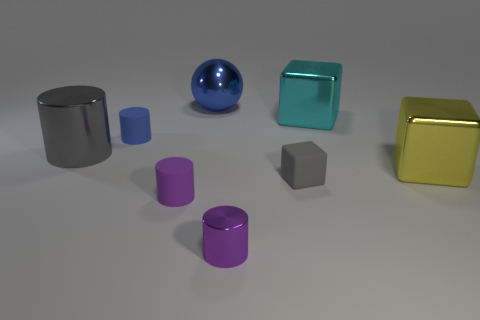Is the shape of the large shiny thing that is on the left side of the small blue cylinder the same as  the large yellow metal object?
Provide a succinct answer. No. The block that is the same size as the blue rubber cylinder is what color?
Give a very brief answer. Gray. How many small cyan matte blocks are there?
Your answer should be compact. 0. Are the small purple object right of the blue ball and the yellow object made of the same material?
Your response must be concise. Yes. There is a tiny object that is both to the left of the blue metallic thing and behind the purple rubber cylinder; what is its material?
Give a very brief answer. Rubber. There is a cylinder that is the same color as the small matte block; what size is it?
Your answer should be compact. Large. There is a large object in front of the big thing left of the blue cylinder; what is it made of?
Ensure brevity in your answer.  Metal. There is a rubber cylinder that is in front of the tiny matte cylinder behind the gray thing that is behind the matte block; how big is it?
Keep it short and to the point. Small. What number of cubes have the same material as the blue sphere?
Give a very brief answer. 2. There is a small thing that is on the right side of the tiny purple cylinder that is right of the blue metallic ball; what is its color?
Your answer should be compact. Gray. 